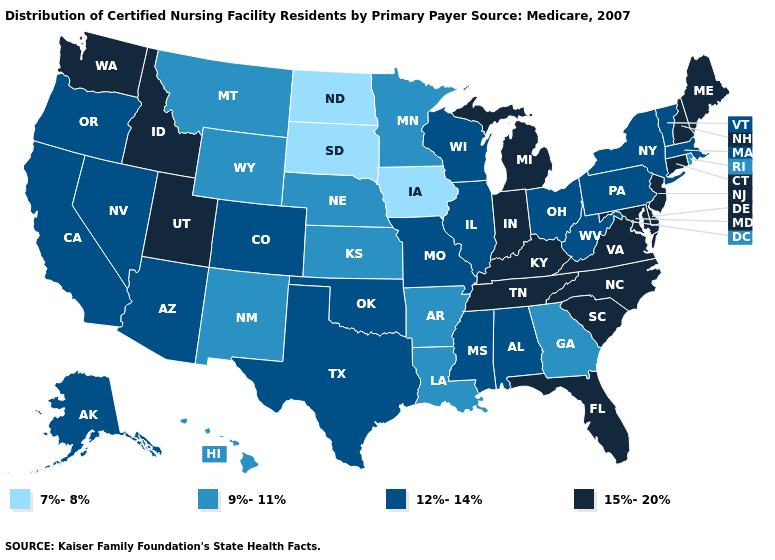Which states have the highest value in the USA?
Keep it brief. Connecticut, Delaware, Florida, Idaho, Indiana, Kentucky, Maine, Maryland, Michigan, New Hampshire, New Jersey, North Carolina, South Carolina, Tennessee, Utah, Virginia, Washington. Does Florida have the highest value in the USA?
Write a very short answer. Yes. Does Vermont have a higher value than Kansas?
Give a very brief answer. Yes. Does Georgia have the lowest value in the South?
Answer briefly. Yes. Does Massachusetts have the highest value in the Northeast?
Keep it brief. No. Does North Carolina have the same value as Florida?
Quick response, please. Yes. Does North Dakota have the lowest value in the USA?
Be succinct. Yes. Name the states that have a value in the range 7%-8%?
Answer briefly. Iowa, North Dakota, South Dakota. Which states have the lowest value in the MidWest?
Give a very brief answer. Iowa, North Dakota, South Dakota. What is the value of Louisiana?
Be succinct. 9%-11%. What is the highest value in states that border Idaho?
Keep it brief. 15%-20%. What is the highest value in states that border Pennsylvania?
Give a very brief answer. 15%-20%. Name the states that have a value in the range 9%-11%?
Be succinct. Arkansas, Georgia, Hawaii, Kansas, Louisiana, Minnesota, Montana, Nebraska, New Mexico, Rhode Island, Wyoming. Name the states that have a value in the range 15%-20%?
Answer briefly. Connecticut, Delaware, Florida, Idaho, Indiana, Kentucky, Maine, Maryland, Michigan, New Hampshire, New Jersey, North Carolina, South Carolina, Tennessee, Utah, Virginia, Washington. Which states have the highest value in the USA?
Concise answer only. Connecticut, Delaware, Florida, Idaho, Indiana, Kentucky, Maine, Maryland, Michigan, New Hampshire, New Jersey, North Carolina, South Carolina, Tennessee, Utah, Virginia, Washington. 